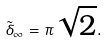<formula> <loc_0><loc_0><loc_500><loc_500>\tilde { \delta } _ { \infty } = \pi \sqrt { 2 } .</formula> 